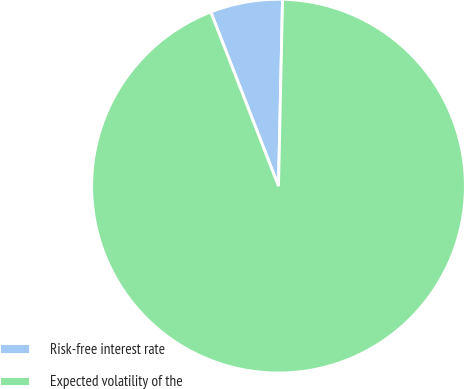<chart> <loc_0><loc_0><loc_500><loc_500><pie_chart><fcel>Risk-free interest rate<fcel>Expected volatility of the<nl><fcel>6.25%<fcel>93.75%<nl></chart> 